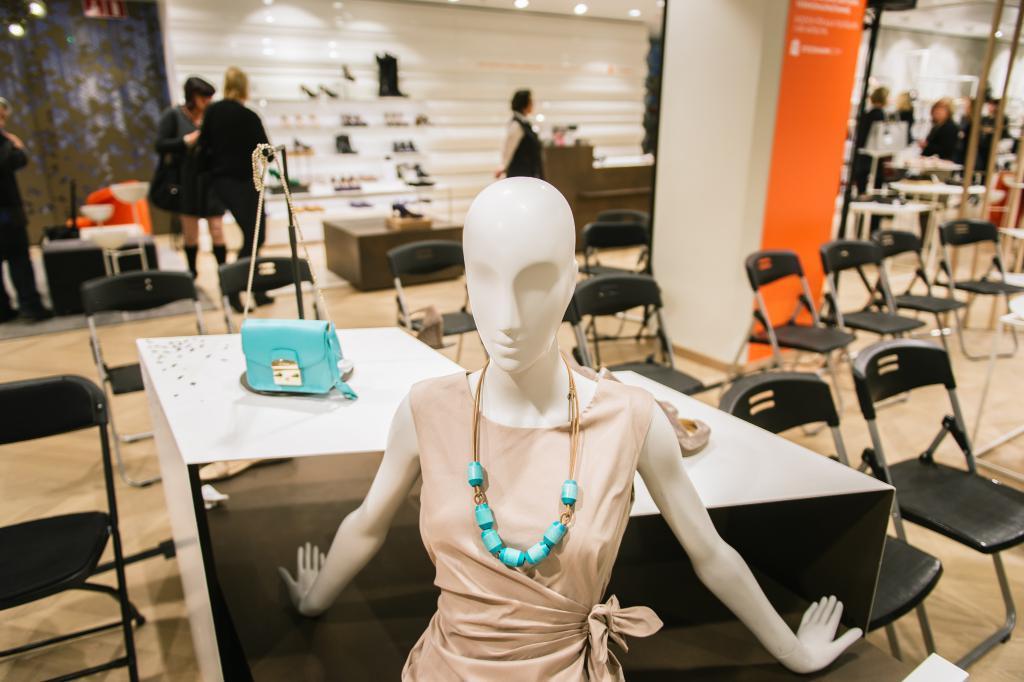Please provide a concise description of this image. This image is taken indoors. At the bottom of the image there is a table with a few things on it and there is a mannequin. In the background there are a few walls, footwear and a table with a few things on it and there are many empty chairs. On the left side of the image a few people are standing on the floor. 